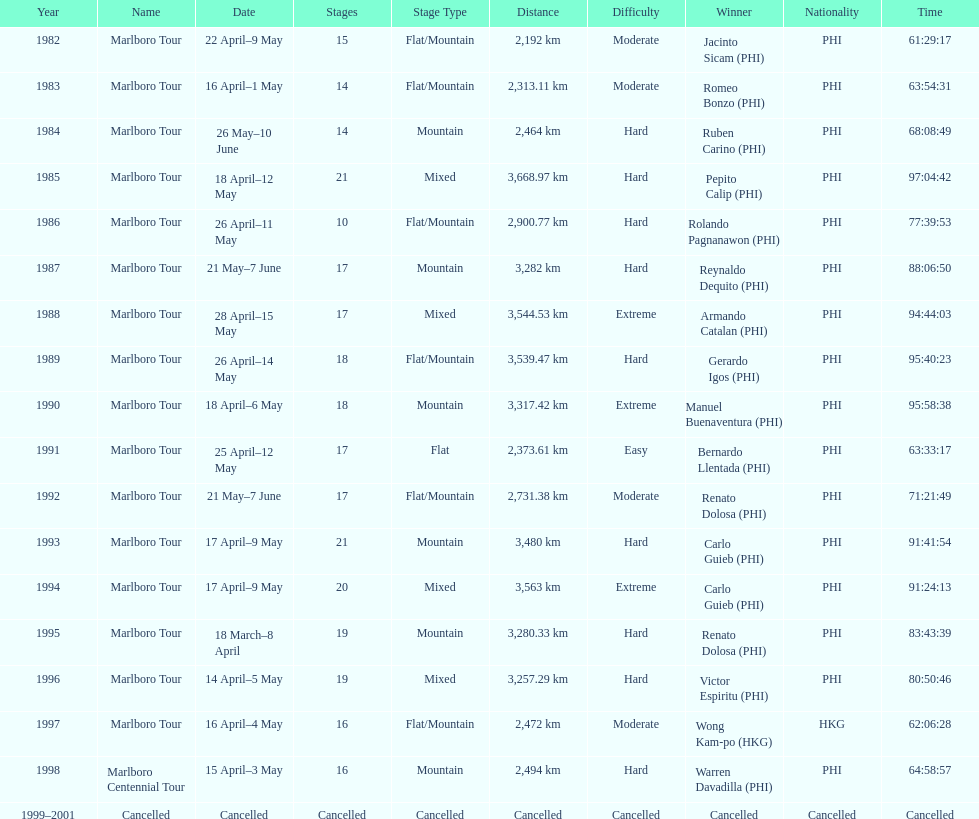Who was the only winner to have their time below 61:45:00? Jacinto Sicam. 